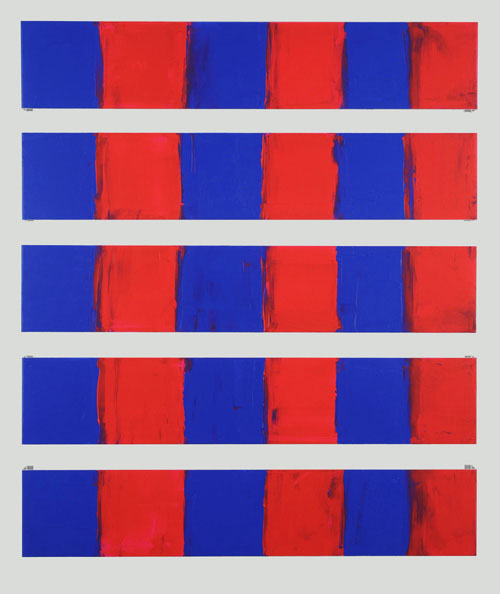Explain the visual content of the image in great detail. The image presents an abstract art piece that is composed of nine rectangular panels, arranged in a grid-like pattern. Each panel is divided into two distinct sections, one colored in red and the other in blue. The red sections give the impression of being painted over the blue ones, adding a layer of depth to the artwork. The arrangement of the panels creates a sense of repetition and symmetry, which is a common characteristic in abstract art. The art style of this piece is reminiscent of color field painting, a genre of abstract art that emphasizes the use of large, unbroken areas of color. 